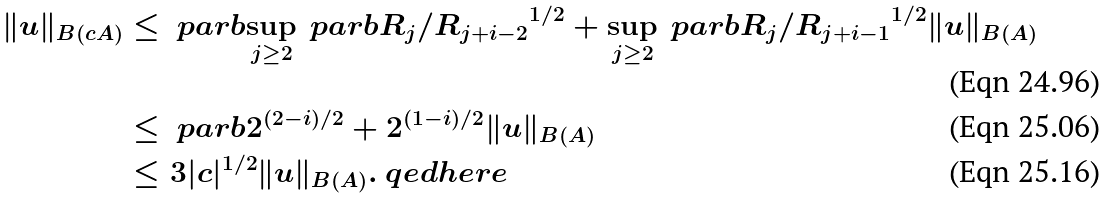<formula> <loc_0><loc_0><loc_500><loc_500>\| u \| _ { B ( c A ) } & \leq \ p a r b { \sup _ { j \geq 2 } \ p a r b { R _ { j } / R _ { j + i - 2 } } ^ { 1 / 2 } + \sup _ { j \geq 2 } \ p a r b { R _ { j } / R _ { j + i - 1 } } ^ { 1 / 2 } } \| u \| _ { B ( A ) } \\ & \leq \ p a r b { 2 ^ { ( 2 - i ) / 2 } + 2 ^ { ( 1 - i ) / 2 } } \| u \| _ { B ( A ) } \\ & \leq 3 | c | ^ { 1 / 2 } \| u \| _ { B ( A ) } . \ q e d h e r e</formula> 